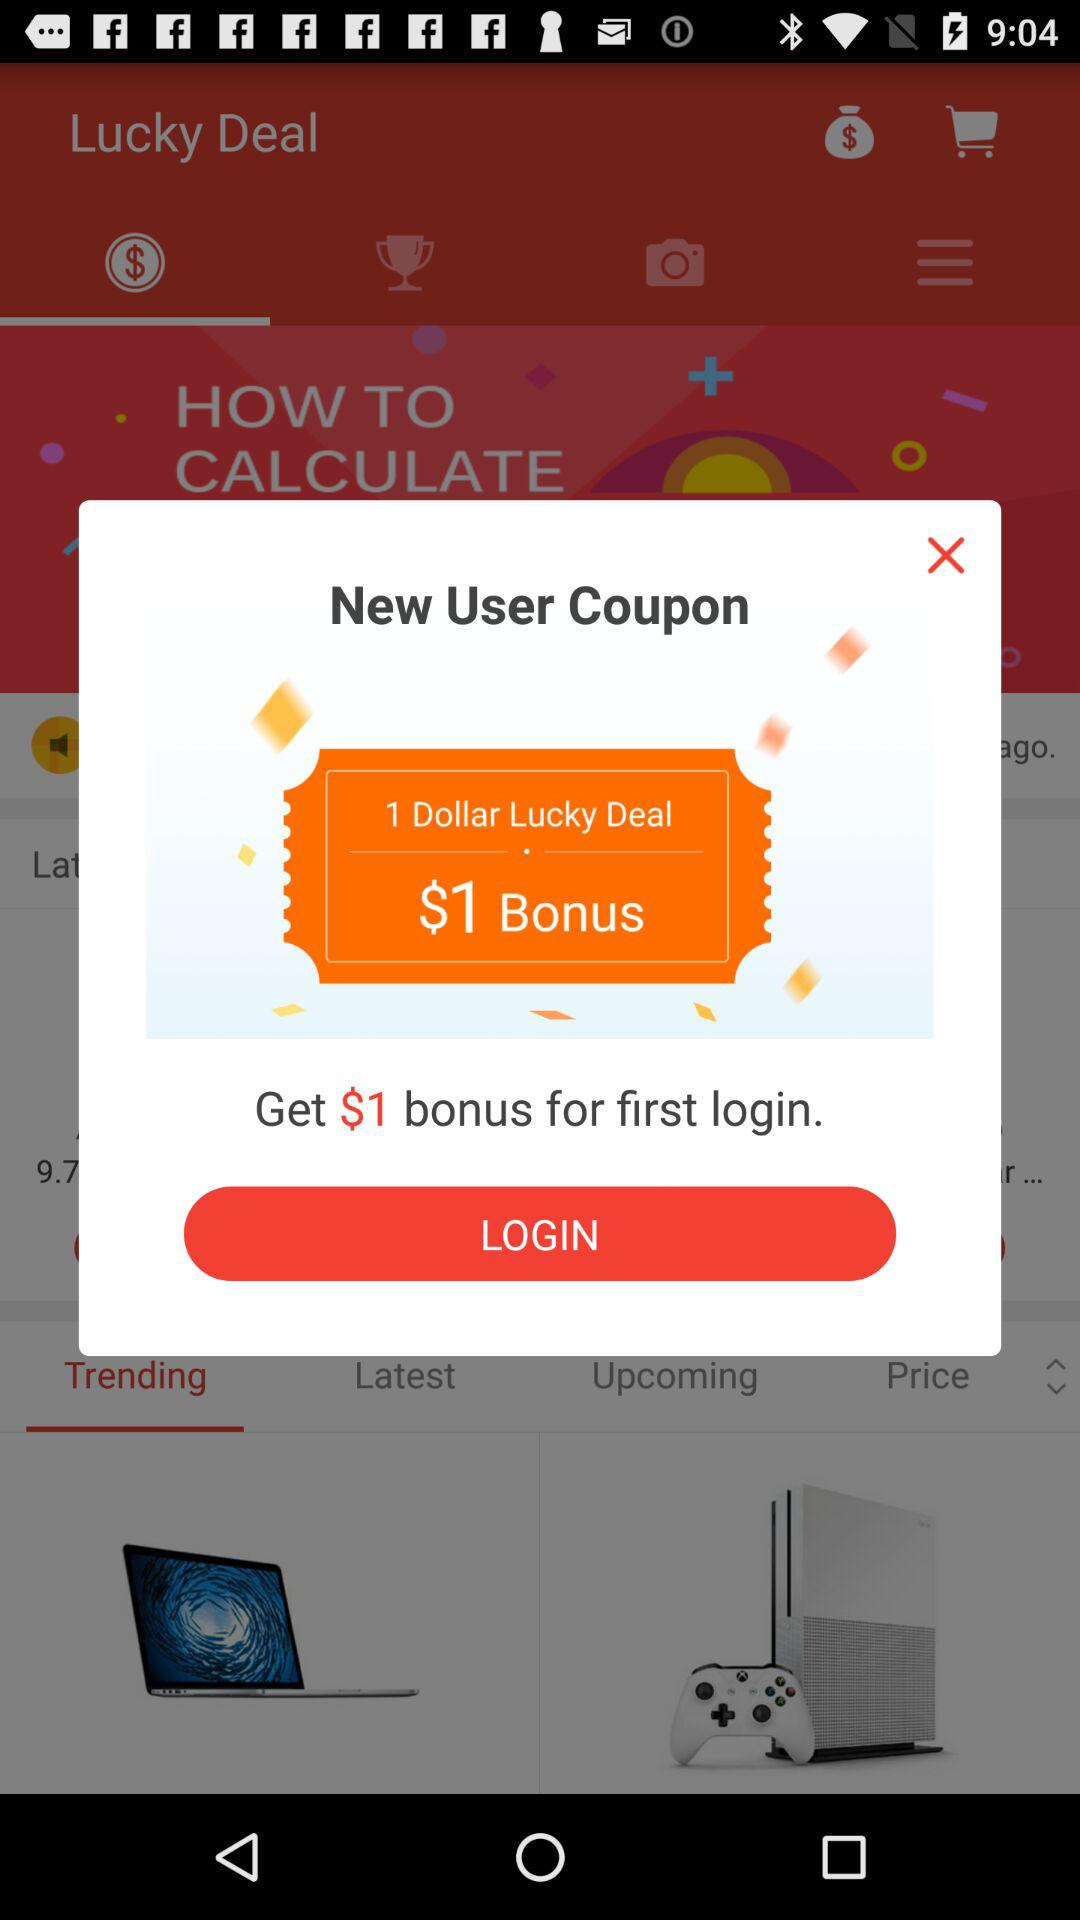How many dollars is the bonus if I use the coupon?
Answer the question using a single word or phrase. $1 